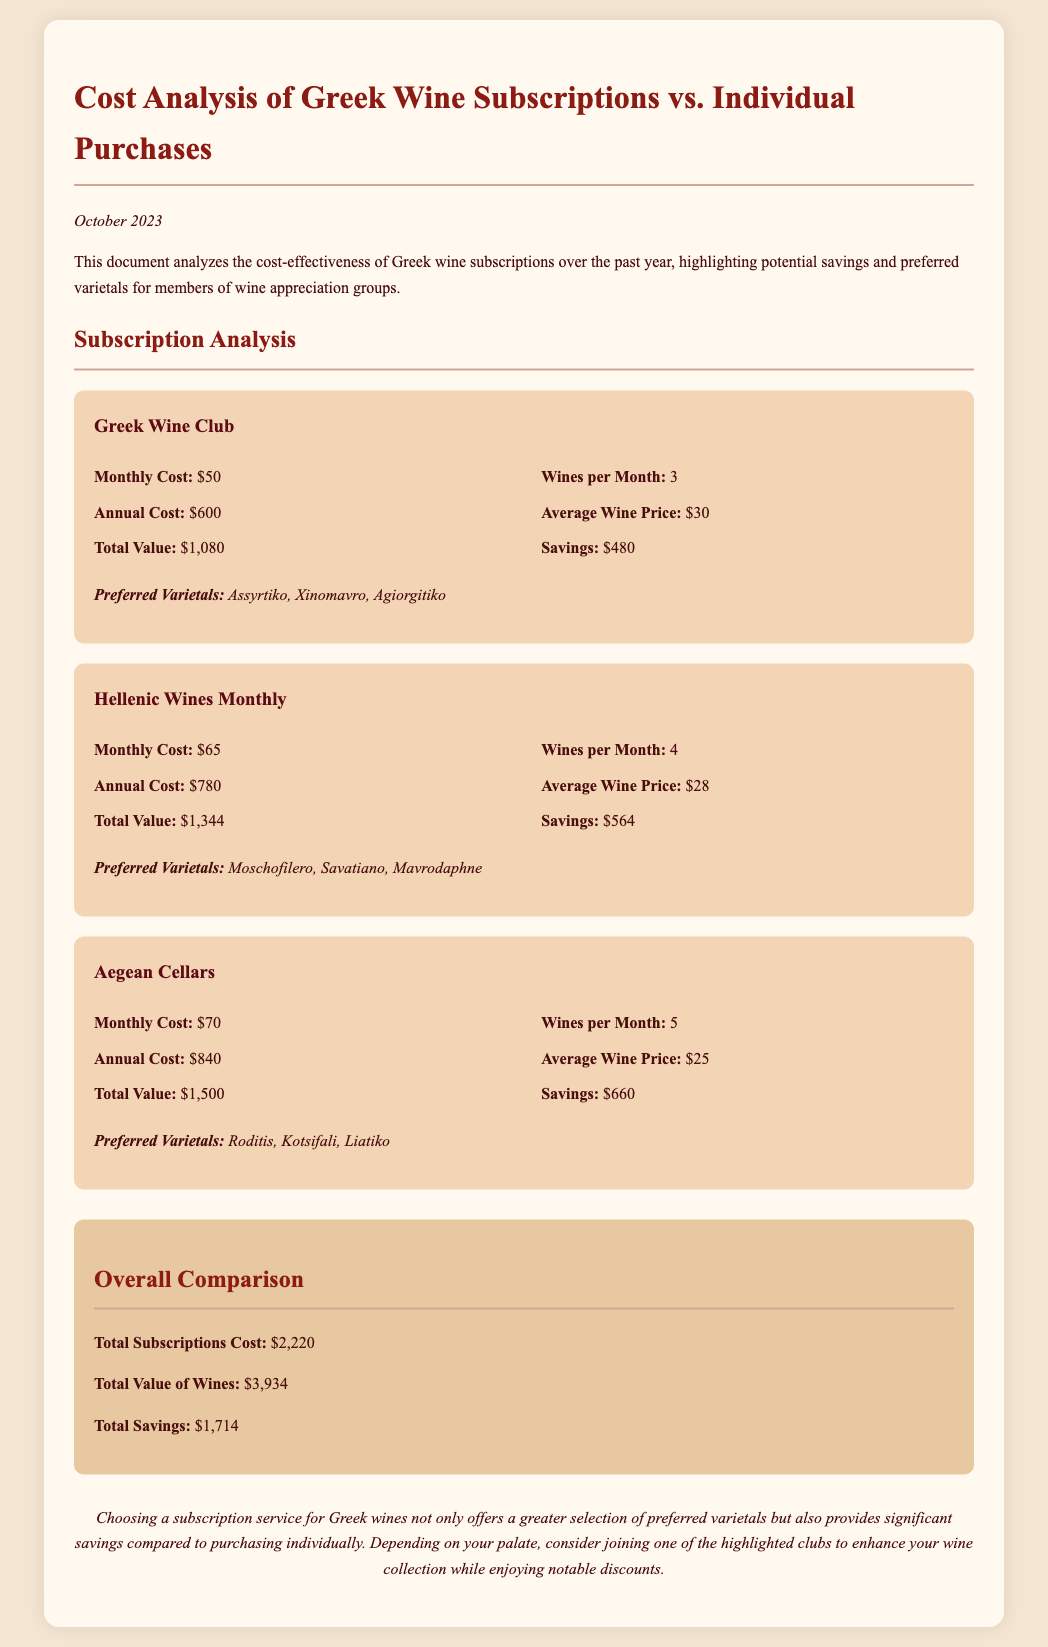What is the monthly cost of Greek Wine Club? The monthly cost is explicitly mentioned in the subscription details for Greek Wine Club.
Answer: $50 What are the preferred varietals for Hellenic Wines Monthly? The document lists the preferred varietals in the subscription details section for Hellenic Wines Monthly.
Answer: Moschofilero, Savatiano, Mavrodaphne How much is the total value of the wines from Aegean Cellars? The total value is stated in the Aegean Cellars subscription details.
Answer: $1,500 What are the total savings from all subscriptions combined? The total savings are listed in the overall comparison section of the document.
Answer: $1,714 What is the annual cost of Aegean Cellars subscription? The annual cost is shown in the subscription details for Aegean Cellars.
Answer: $840 Which subscription offers the highest savings? The highest savings can be inferred by comparing the savings detailed for each subscription.
Answer: Aegean Cellars What is the total number of wines received monthly from Hellenic Wines Monthly? The number of wines is provided in the subscription details for Hellenic Wines Monthly.
Answer: 4 What is the average price per wine in the Greek Wine Club subscription? The average wine price is specified in the subscription details for Greek Wine Club.
Answer: $30 